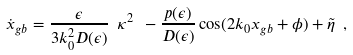Convert formula to latex. <formula><loc_0><loc_0><loc_500><loc_500>\dot { x } _ { g b } = \frac { \epsilon } { 3 k _ { 0 } ^ { 2 } D ( \epsilon ) } \ \kappa ^ { 2 } \ - \frac { p ( \epsilon ) } { D ( \epsilon ) } \cos ( 2 k _ { 0 } x _ { g b } + \phi ) + \tilde { \eta } \ ,</formula> 